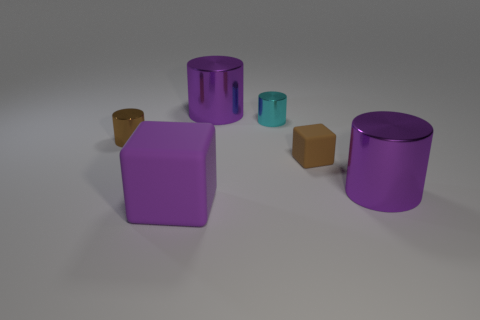Subtract all brown cylinders. How many cylinders are left? 3 Subtract all green cubes. How many purple cylinders are left? 2 Subtract all cyan cylinders. How many cylinders are left? 3 Subtract 2 cylinders. How many cylinders are left? 2 Add 2 purple shiny cylinders. How many objects exist? 8 Subtract all cubes. How many objects are left? 4 Subtract all big matte objects. Subtract all matte things. How many objects are left? 3 Add 3 brown shiny objects. How many brown shiny objects are left? 4 Add 3 brown shiny cylinders. How many brown shiny cylinders exist? 4 Subtract 0 blue cylinders. How many objects are left? 6 